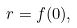Convert formula to latex. <formula><loc_0><loc_0><loc_500><loc_500>r = f ( 0 ) ,</formula> 